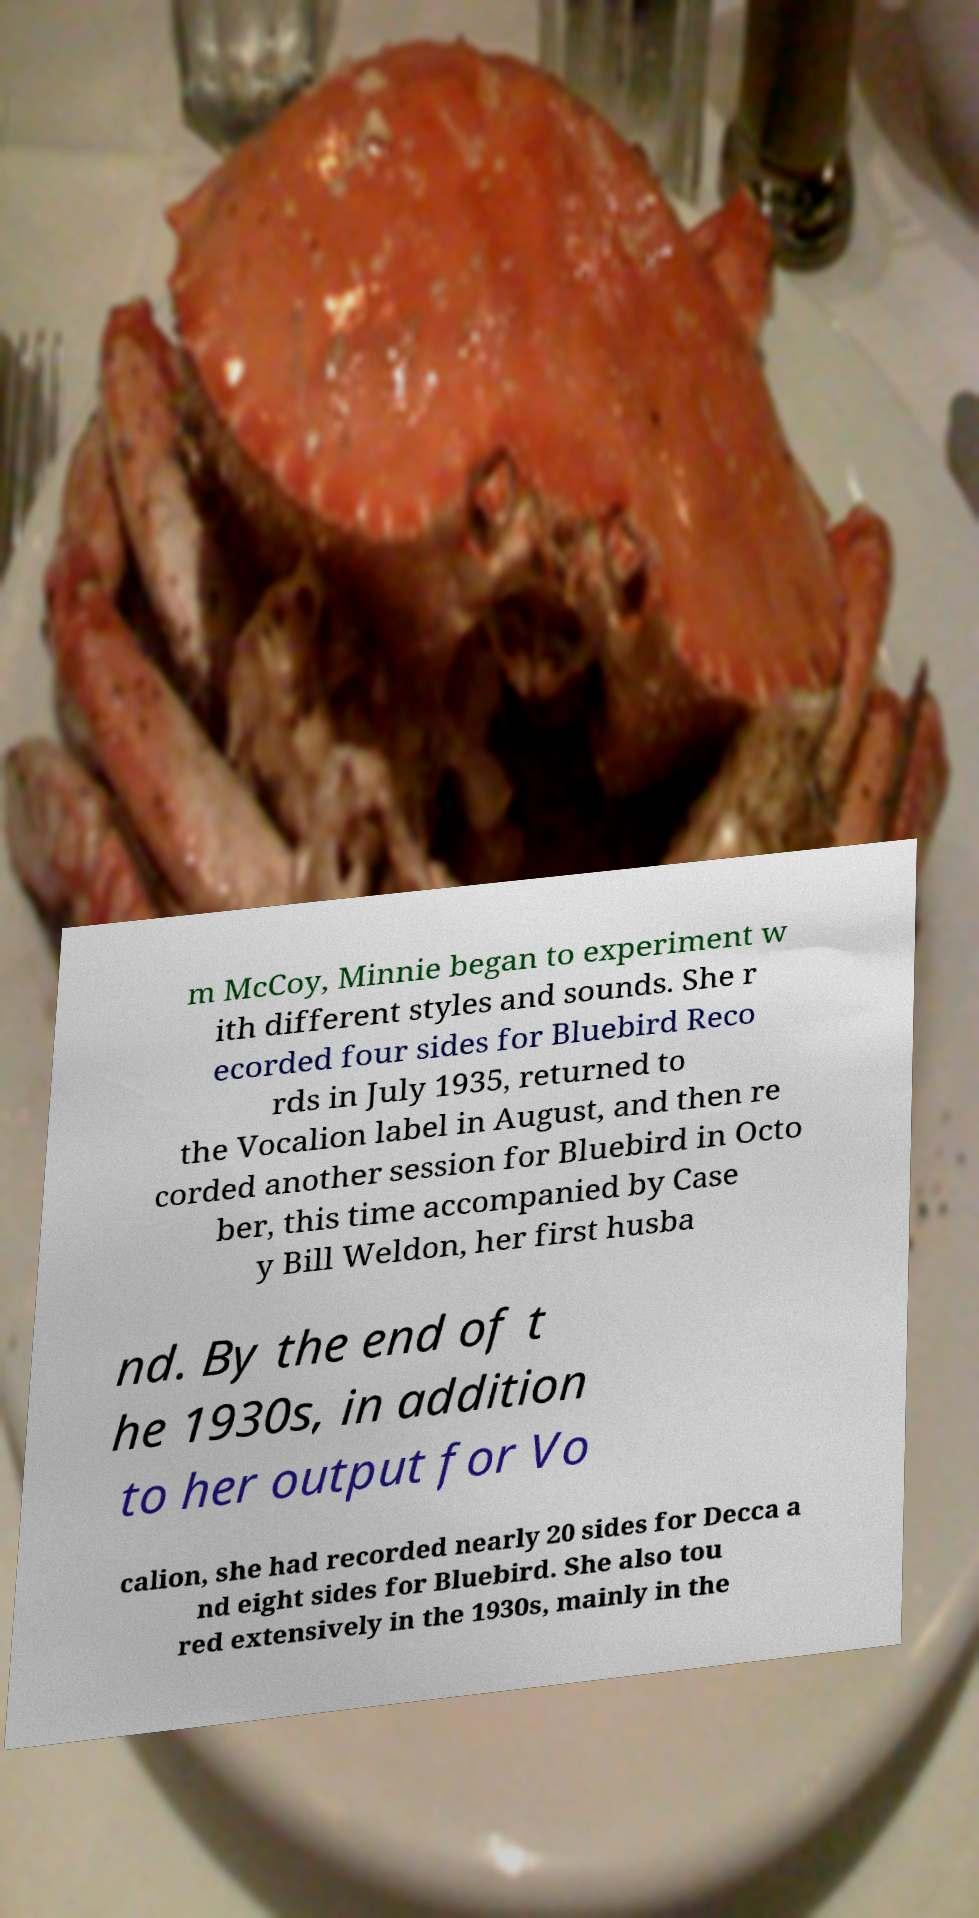Could you assist in decoding the text presented in this image and type it out clearly? m McCoy, Minnie began to experiment w ith different styles and sounds. She r ecorded four sides for Bluebird Reco rds in July 1935, returned to the Vocalion label in August, and then re corded another session for Bluebird in Octo ber, this time accompanied by Case y Bill Weldon, her first husba nd. By the end of t he 1930s, in addition to her output for Vo calion, she had recorded nearly 20 sides for Decca a nd eight sides for Bluebird. She also tou red extensively in the 1930s, mainly in the 